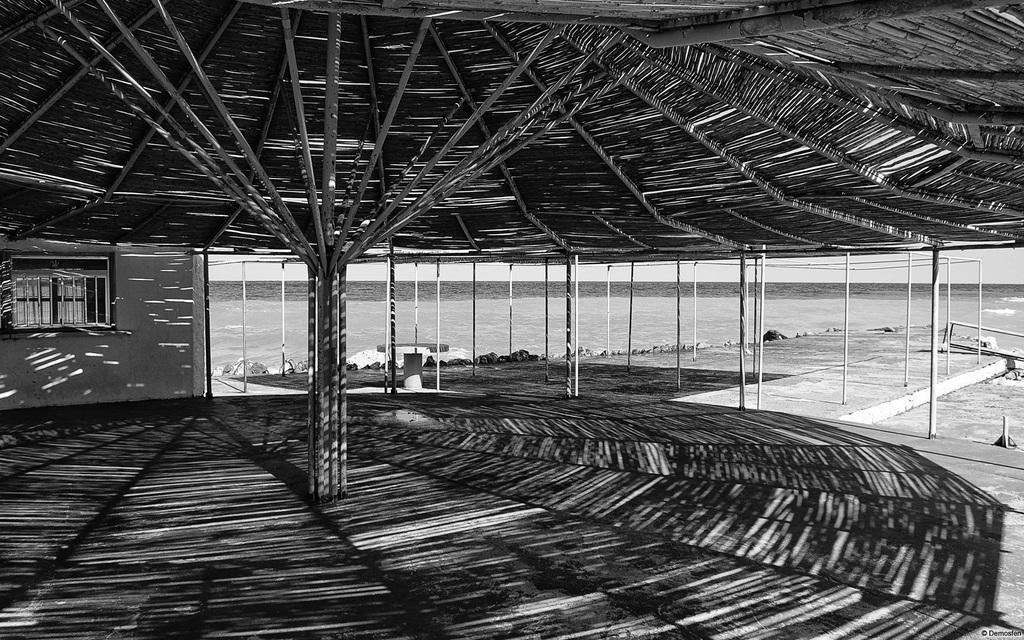How would you summarize this image in a sentence or two? This image is clicked near the beach. It looks like a hut made up of wood. To the left, there is a wall along with window. In the front, there are poles. In the background, there is water. 